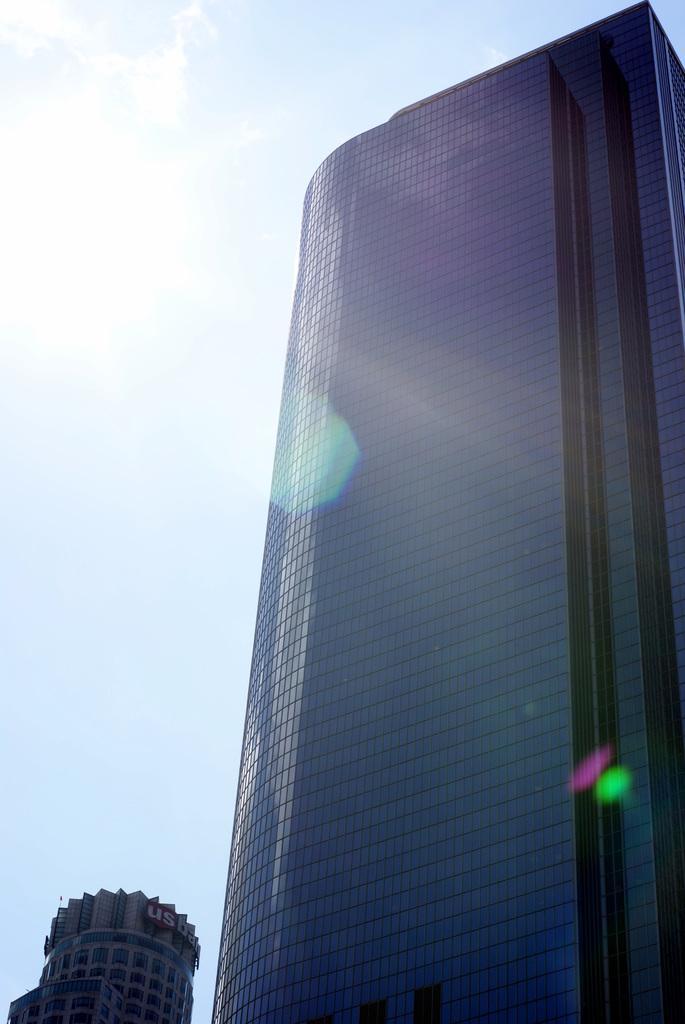Describe this image in one or two sentences. In this image I see the buildings and I see the sky which is clear and I see the sun over here. 